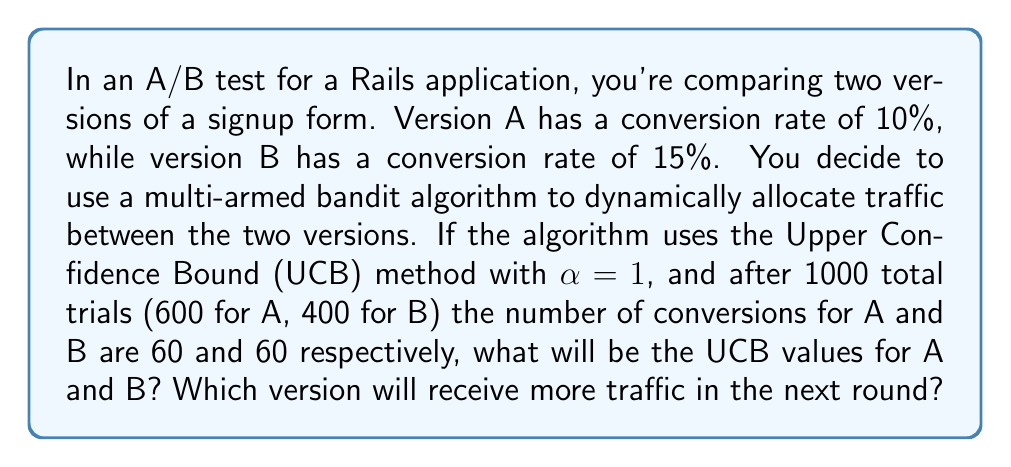What is the answer to this math problem? To solve this problem, we need to understand the Upper Confidence Bound (UCB) algorithm and apply it to our A/B testing scenario. The UCB algorithm balances exploration and exploitation in multi-armed bandit problems.

The UCB formula is:

$$UCB_i = \bar{X_i} + \sqrt{\frac{2\ln{n}}{n_i}}$$

Where:
- $\bar{X_i}$ is the average reward (conversion rate) for arm i
- $n$ is the total number of trials
- $n_i$ is the number of trials for arm i
- $\alpha$ is a parameter that controls the exploration-exploitation trade-off (given as 1 in this case)

Let's calculate the UCB values for both versions:

For Version A:
- $n_A = 600$
- Conversions = 60
- $\bar{X_A} = 60 / 600 = 0.1$

$$UCB_A = 0.1 + \sqrt{\frac{2\ln{1000}}{600}} \approx 0.1 + 0.0837 \approx 0.1837$$

For Version B:
- $n_B = 400$
- Conversions = 60
- $\bar{X_B} = 60 / 400 = 0.15$

$$UCB_B = 0.15 + \sqrt{\frac{2\ln{1000}}{400}} \approx 0.15 + 0.1025 \approx 0.2525$$

The UCB value for Version B (0.2525) is higher than Version A (0.1837), despite having fewer total trials. This is because Version B has a higher conversion rate and the algorithm is accounting for the uncertainty due to fewer trials.
Answer: The UCB values are approximately 0.1837 for Version A and 0.2525 for Version B. Version B will receive more traffic in the next round because it has a higher UCB value. 